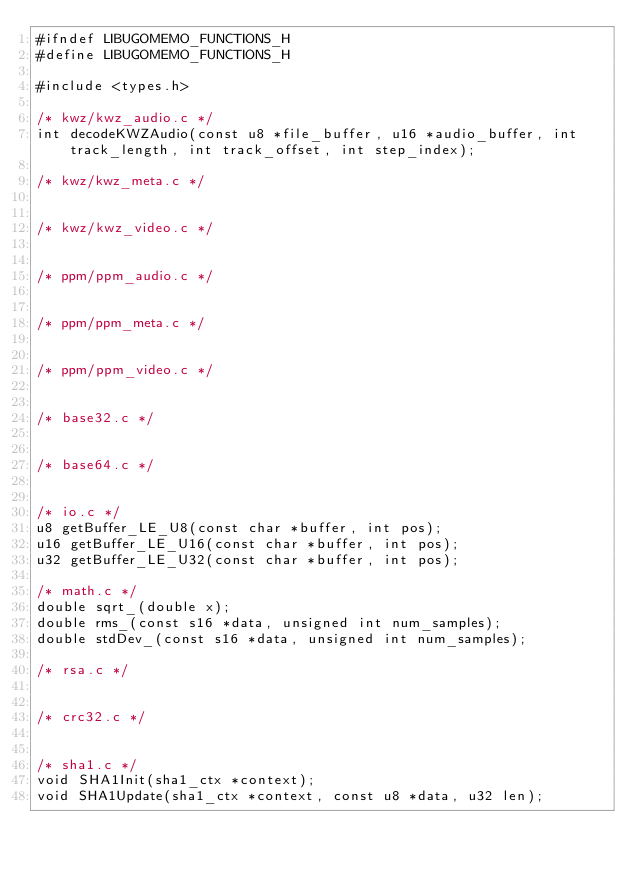<code> <loc_0><loc_0><loc_500><loc_500><_C_>#ifndef LIBUGOMEMO_FUNCTIONS_H
#define LIBUGOMEMO_FUNCTIONS_H

#include <types.h>

/* kwz/kwz_audio.c */
int decodeKWZAudio(const u8 *file_buffer, u16 *audio_buffer, int track_length, int track_offset, int step_index);

/* kwz/kwz_meta.c */


/* kwz/kwz_video.c */


/* ppm/ppm_audio.c */


/* ppm/ppm_meta.c */


/* ppm/ppm_video.c */


/* base32.c */


/* base64.c */


/* io.c */
u8 getBuffer_LE_U8(const char *buffer, int pos);
u16 getBuffer_LE_U16(const char *buffer, int pos);
u32 getBuffer_LE_U32(const char *buffer, int pos);

/* math.c */
double sqrt_(double x);
double rms_(const s16 *data, unsigned int num_samples);
double stdDev_(const s16 *data, unsigned int num_samples);

/* rsa.c */


/* crc32.c */


/* sha1.c */
void SHA1Init(sha1_ctx *context);
void SHA1Update(sha1_ctx *context, const u8 *data, u32 len);</code> 